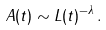<formula> <loc_0><loc_0><loc_500><loc_500>A ( t ) \sim L ( t ) ^ { - \lambda } \, .</formula> 